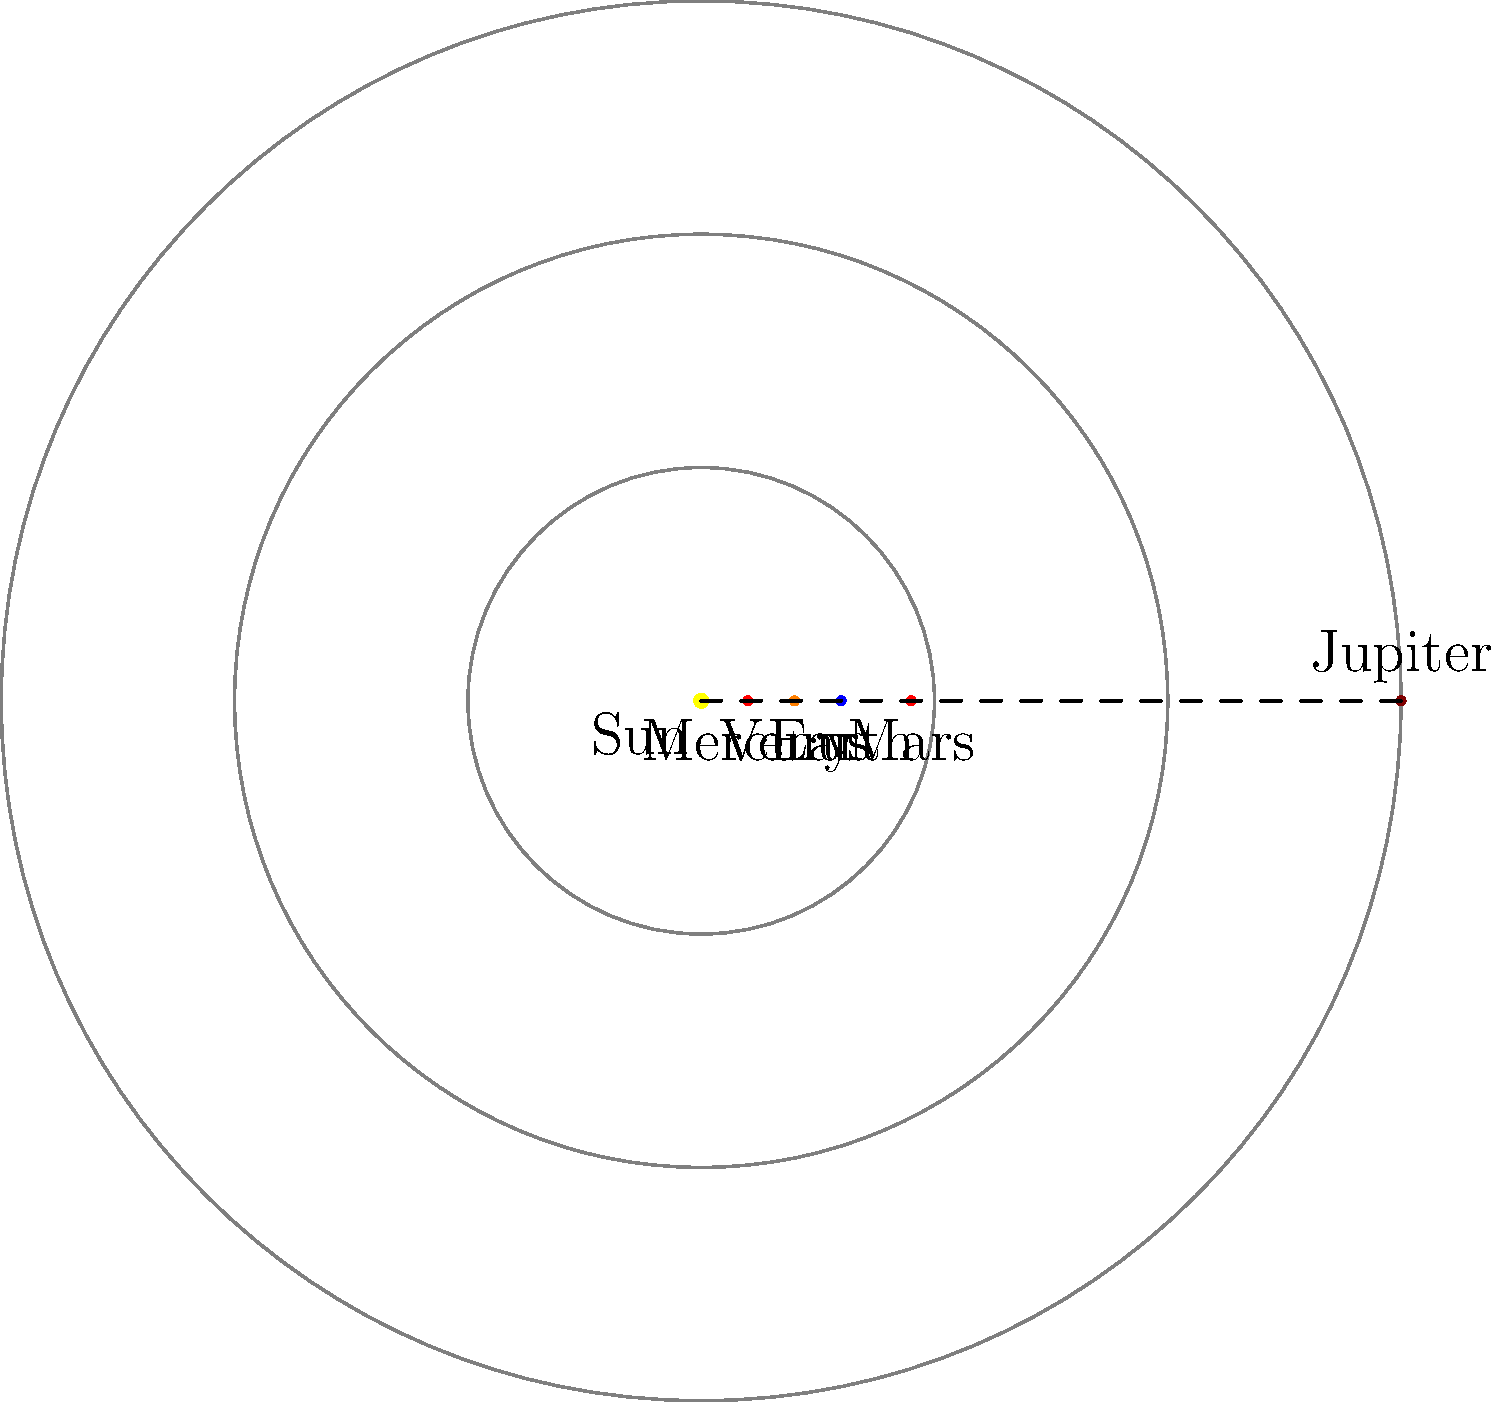As an athletics director, you often discuss distances and relative positions. In this scaled diagram of our solar system, where 1 Astronomical Unit (AU) represents 3 units on the diagram, what is the approximate distance between Mars and Jupiter in AU? To solve this problem, let's approach it step-by-step:

1. First, we need to identify the positions of Mars and Jupiter on the diagram:
   - Mars is at 4.5 units from the Sun
   - Jupiter is at 15 units from the Sun

2. We're told that 1 AU is represented by 3 units on the diagram. So we can convert the diagram units to AU:
   - Mars: $4.5 \div 3 = 1.5$ AU
   - Jupiter: $15 \div 3 = 5$ AU

3. To find the distance between Mars and Jupiter, we subtract their distances from the Sun:
   $5 \text{ AU} - 1.5 \text{ AU} = 3.5 \text{ AU}$

4. Therefore, the approximate distance between Mars and Jupiter is 3.5 AU.

This calculation mirrors how we might measure the distance between two athletes on a track, emphasizing the importance of understanding relative positions and distances in both astronomy and athletics.
Answer: 3.5 AU 